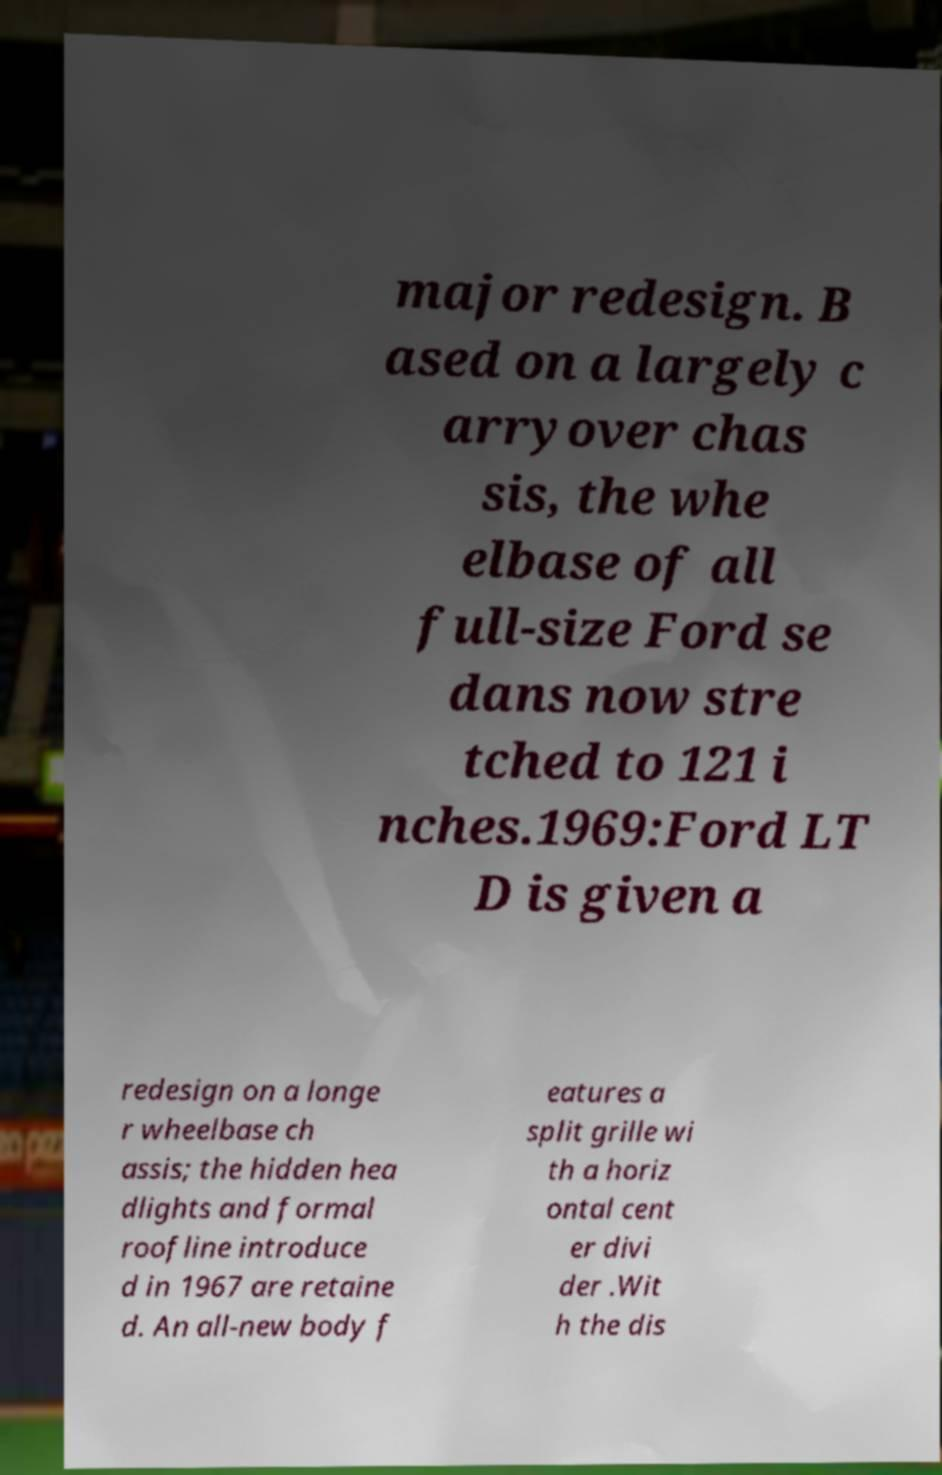Please identify and transcribe the text found in this image. major redesign. B ased on a largely c arryover chas sis, the whe elbase of all full-size Ford se dans now stre tched to 121 i nches.1969:Ford LT D is given a redesign on a longe r wheelbase ch assis; the hidden hea dlights and formal roofline introduce d in 1967 are retaine d. An all-new body f eatures a split grille wi th a horiz ontal cent er divi der .Wit h the dis 